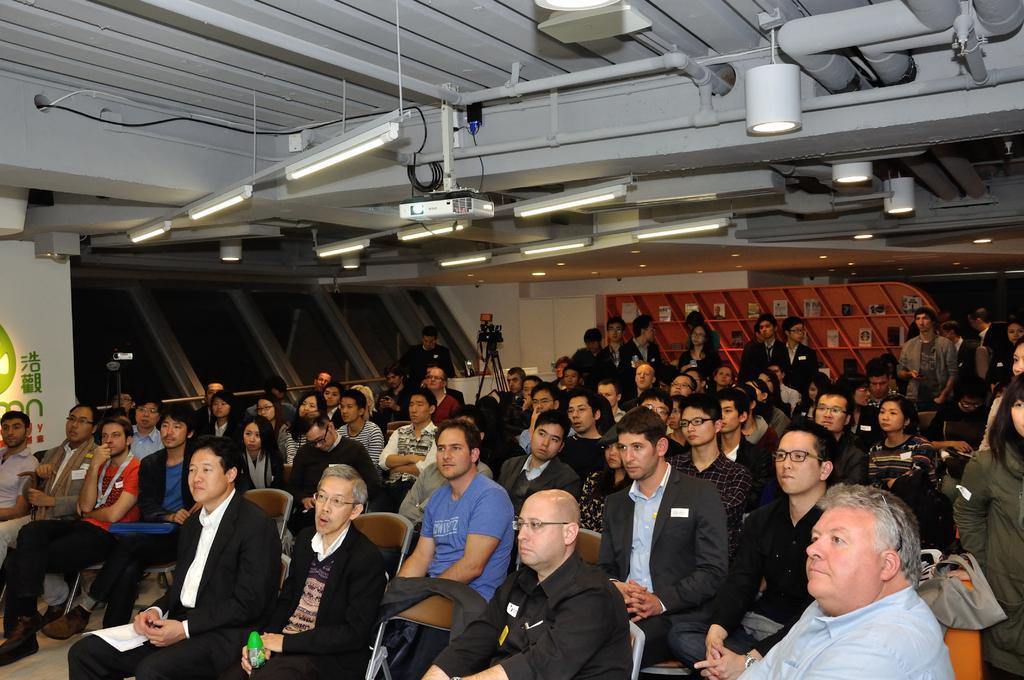In one or two sentences, can you explain what this image depicts? In this image at the bottom there are a group of people who are sitting and some of them are standing, at the top there is one projector and some lights and pipes and ceiling. In the background there is a wall and some boards, and also we could see some cameras. 